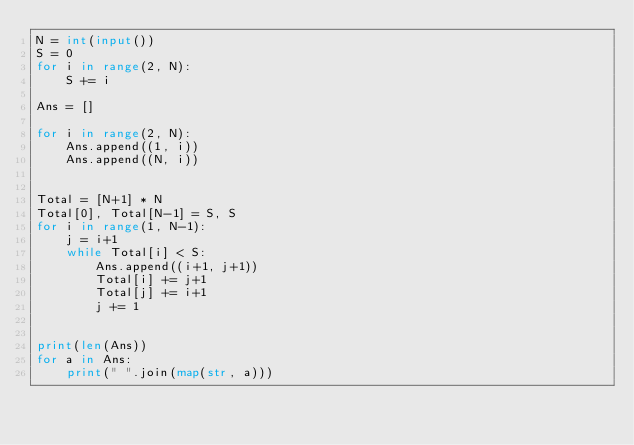Convert code to text. <code><loc_0><loc_0><loc_500><loc_500><_Python_>N = int(input())
S = 0
for i in range(2, N):
    S += i

Ans = []

for i in range(2, N):
    Ans.append((1, i))
    Ans.append((N, i))
  

Total = [N+1] * N
Total[0], Total[N-1] = S, S
for i in range(1, N-1):
    j = i+1
    while Total[i] < S:
        Ans.append((i+1, j+1))
        Total[i] += j+1
        Total[j] += i+1
        j += 1
       

print(len(Ans))
for a in Ans:
    print(" ".join(map(str, a)))</code> 